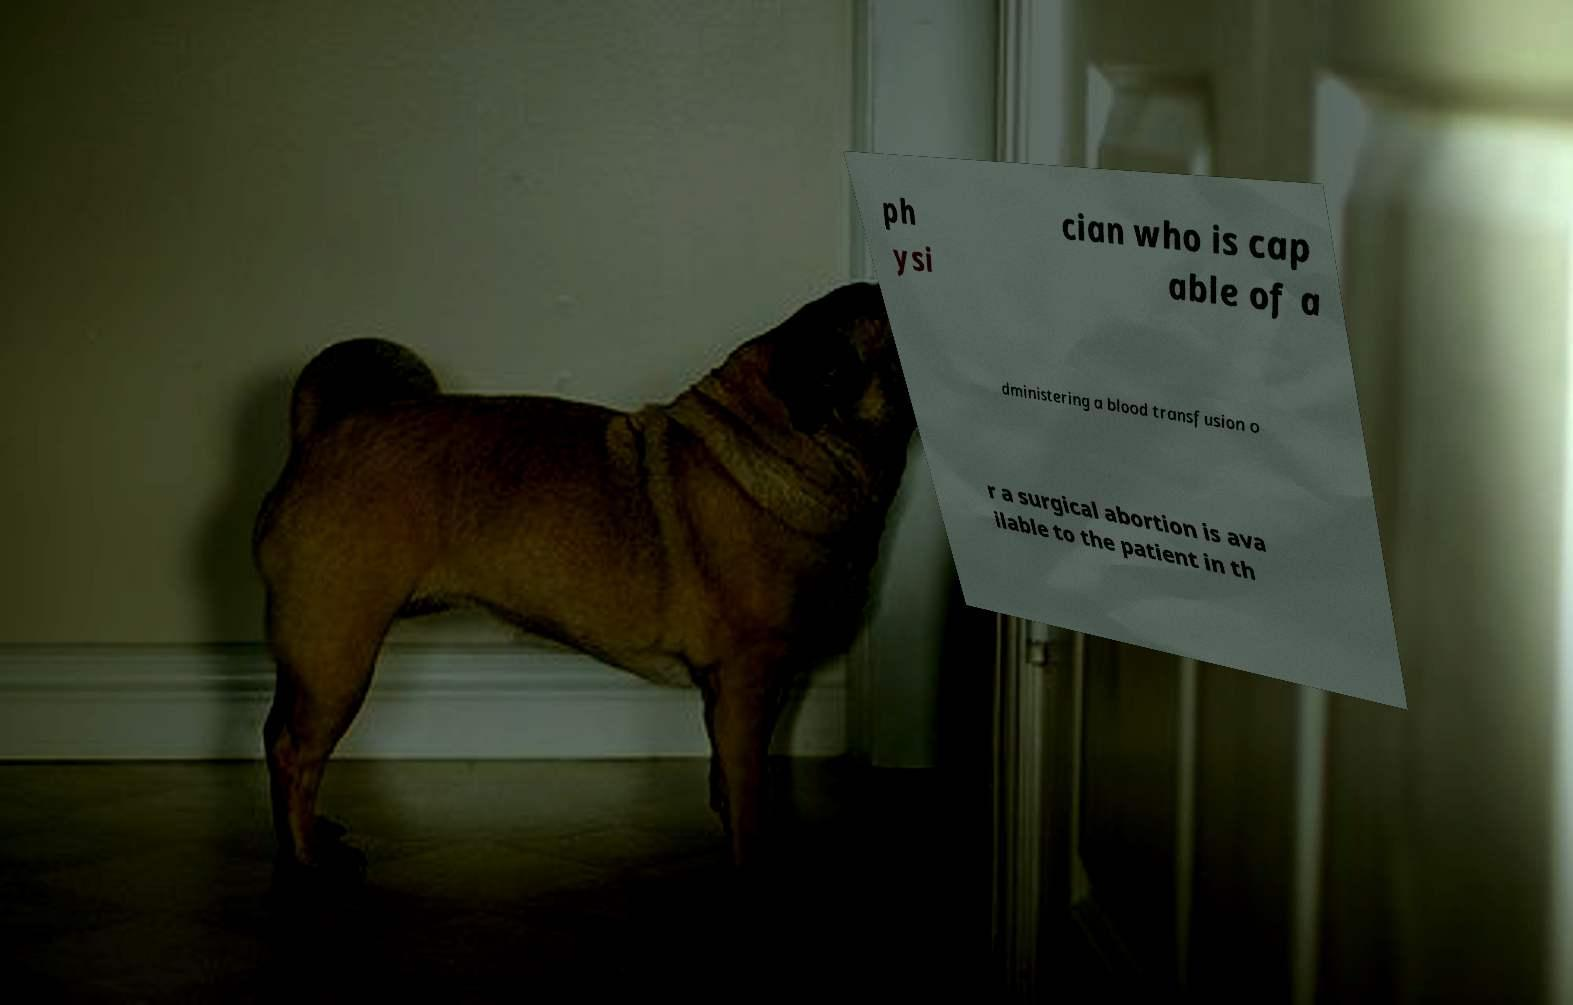Can you read and provide the text displayed in the image?This photo seems to have some interesting text. Can you extract and type it out for me? ph ysi cian who is cap able of a dministering a blood transfusion o r a surgical abortion is ava ilable to the patient in th 